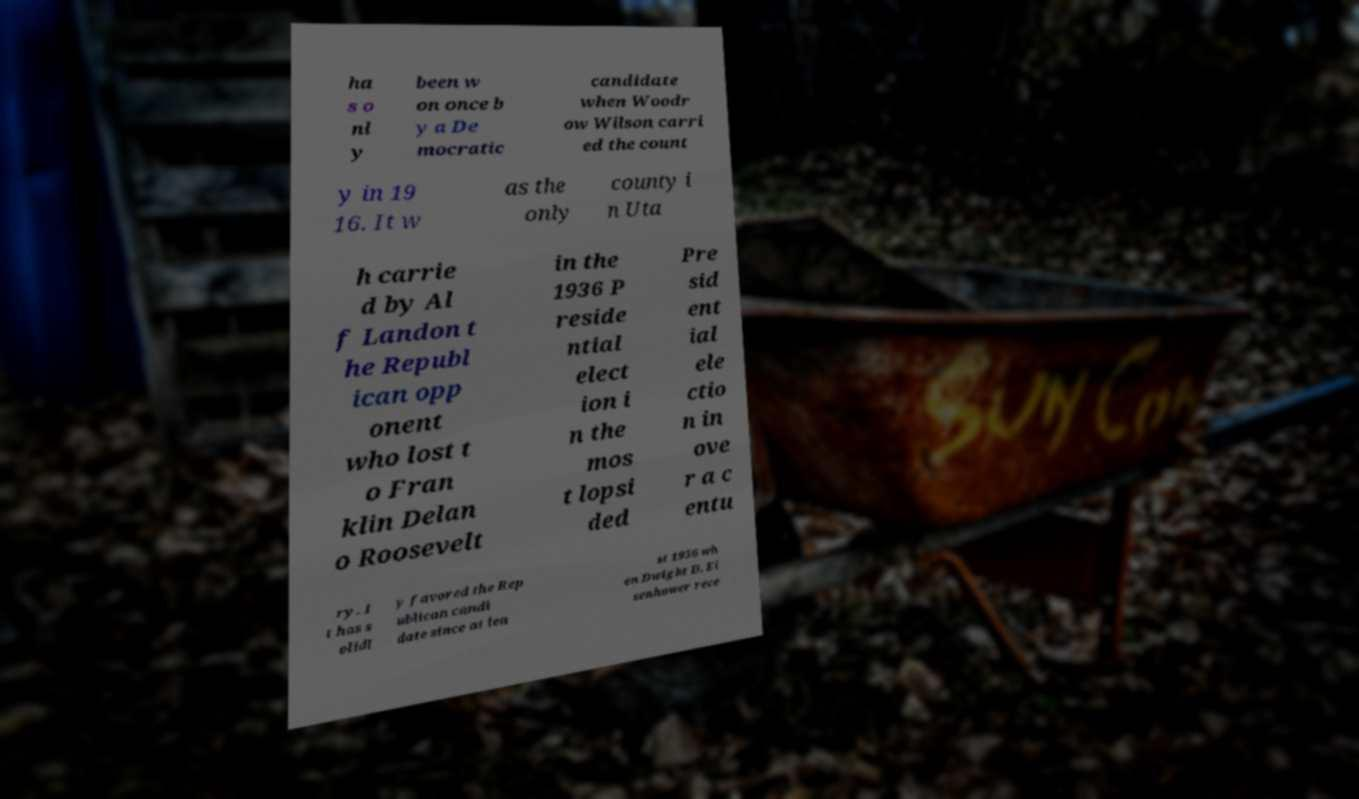Can you accurately transcribe the text from the provided image for me? ha s o nl y been w on once b y a De mocratic candidate when Woodr ow Wilson carri ed the count y in 19 16. It w as the only county i n Uta h carrie d by Al f Landon t he Republ ican opp onent who lost t o Fran klin Delan o Roosevelt in the 1936 P reside ntial elect ion i n the mos t lopsi ded Pre sid ent ial ele ctio n in ove r a c entu ry. I t has s olidl y favored the Rep ublican candi date since at lea st 1956 wh en Dwight D. Ei senhower rece 